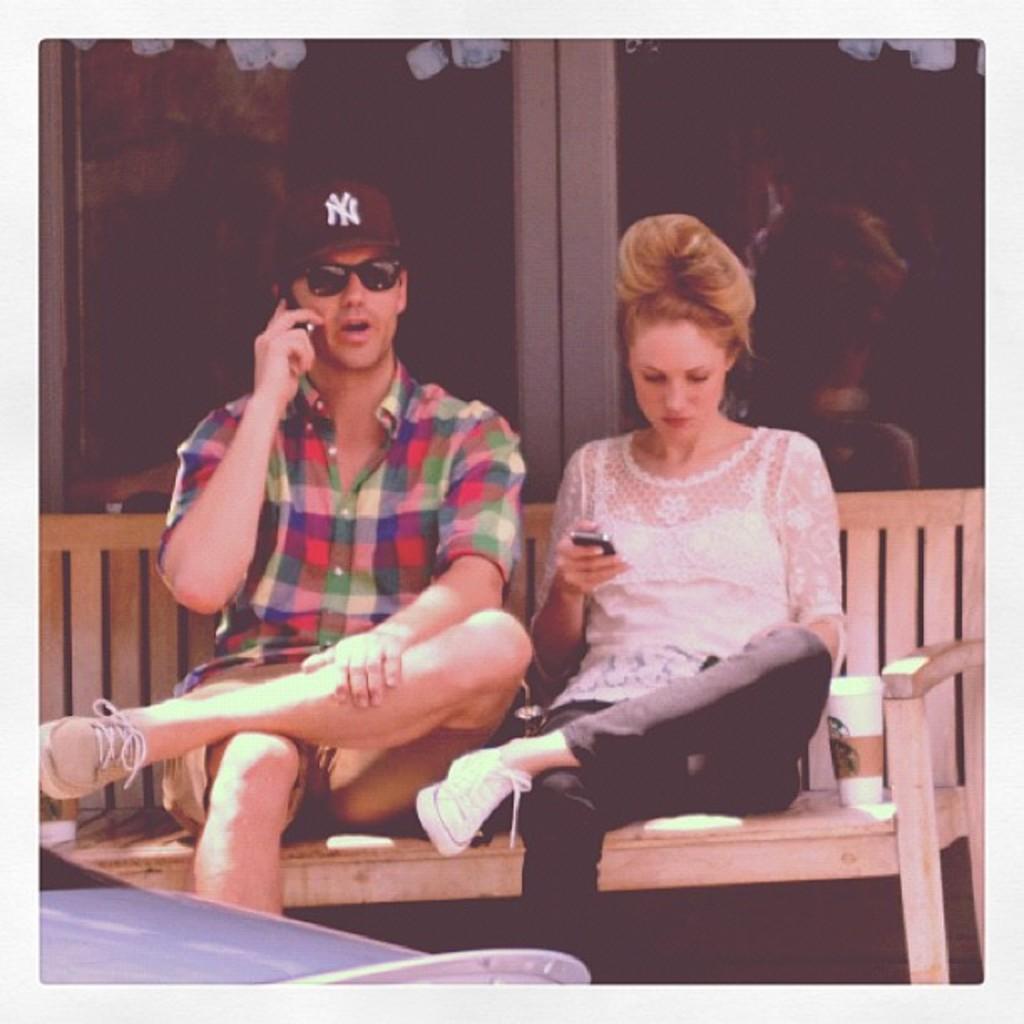Could you give a brief overview of what you see in this image? In the picture I can see a man and a woman are sitting on a bench. The man is holding a mobile in the hand. The man is wearing a cap, black color shades and shoes. On the bench I can see a glass. In the background I can see glass walls. 